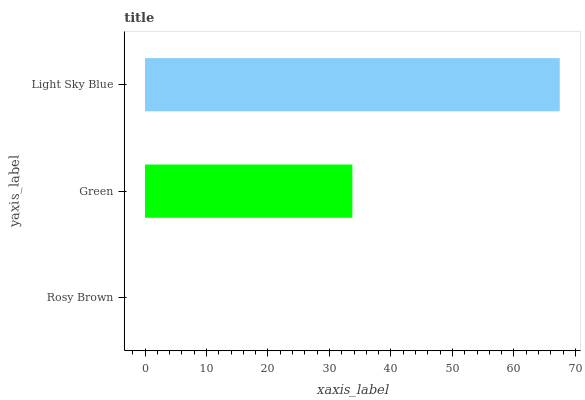Is Rosy Brown the minimum?
Answer yes or no. Yes. Is Light Sky Blue the maximum?
Answer yes or no. Yes. Is Green the minimum?
Answer yes or no. No. Is Green the maximum?
Answer yes or no. No. Is Green greater than Rosy Brown?
Answer yes or no. Yes. Is Rosy Brown less than Green?
Answer yes or no. Yes. Is Rosy Brown greater than Green?
Answer yes or no. No. Is Green less than Rosy Brown?
Answer yes or no. No. Is Green the high median?
Answer yes or no. Yes. Is Green the low median?
Answer yes or no. Yes. Is Rosy Brown the high median?
Answer yes or no. No. Is Rosy Brown the low median?
Answer yes or no. No. 